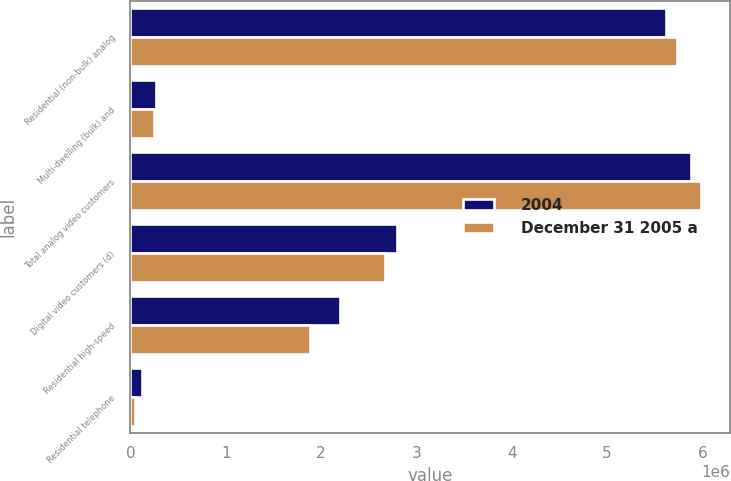Convert chart. <chart><loc_0><loc_0><loc_500><loc_500><stacked_bar_chart><ecel><fcel>Residential (non-bulk) analog<fcel>Multi-dwelling (bulk) and<fcel>Total analog video customers<fcel>Digital video customers (d)<fcel>Residential high-speed<fcel>Residential telephone<nl><fcel>2004<fcel>5.6163e+06<fcel>268200<fcel>5.8845e+06<fcel>2.7966e+06<fcel>2.1964e+06<fcel>121500<nl><fcel>December 31 2005 a<fcel>5.7399e+06<fcel>251600<fcel>5.9915e+06<fcel>2.6747e+06<fcel>1.8844e+06<fcel>45400<nl></chart> 